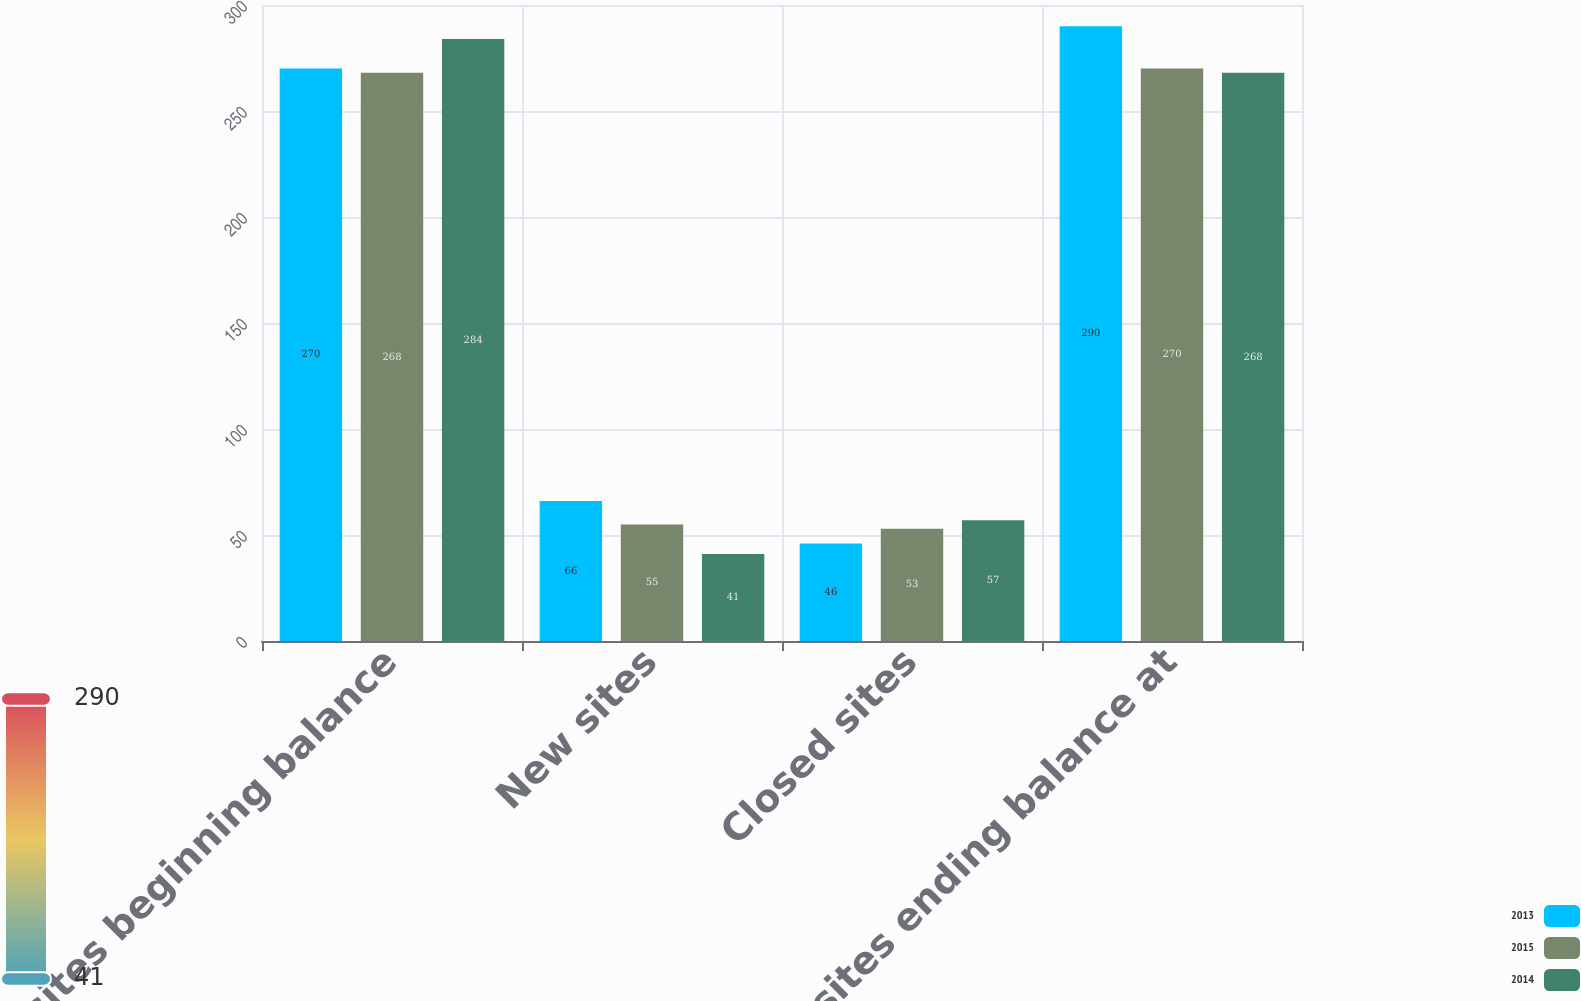Convert chart. <chart><loc_0><loc_0><loc_500><loc_500><stacked_bar_chart><ecel><fcel>Open sites beginning balance<fcel>New sites<fcel>Closed sites<fcel>Open sites ending balance at<nl><fcel>2013<fcel>270<fcel>66<fcel>46<fcel>290<nl><fcel>2015<fcel>268<fcel>55<fcel>53<fcel>270<nl><fcel>2014<fcel>284<fcel>41<fcel>57<fcel>268<nl></chart> 